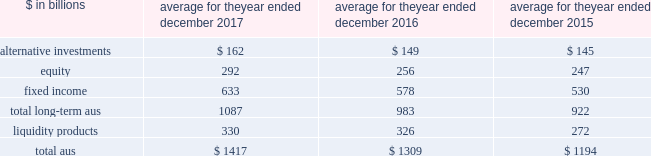The goldman sachs group , inc .
And subsidiaries management 2019s discussion and analysis the table below presents our average monthly assets under supervision by asset class .
Average for the year ended december $ in billions 2017 2016 2015 .
Operating environment .
During 2017 , investment management operated in an environment characterized by generally higher asset prices , resulting in appreciation in both equity and fixed income assets .
In addition , our long- term assets under supervision increased from net inflows primarily in fixed income and alternative investment assets .
These increases were partially offset by net outflows in liquidity products .
As a result , the mix of average assets under supervision during 2017 shifted slightly from liquidity products to long-term assets under supervision as compared to the mix at the end of 2016 .
In the future , if asset prices decline , or investors favor assets that typically generate lower fees or investors withdraw their assets , net revenues in investment management would likely be negatively impacted .
Following a challenging first quarter of 2016 , market conditions improved during the remainder of 2016 with higher asset prices resulting in full year appreciation in both equity and fixed income assets .
Also , our assets under supervision increased during 2016 from net inflows , primarily in fixed income assets , and liquidity products .
The mix of our average assets under supervision shifted slightly compared with 2015 from long-term assets under supervision to liquidity products .
Management fees were impacted by many factors , including inflows to advisory services and outflows from actively-managed mutual funds .
2017 versus 2016 .
Net revenues in investment management were $ 6.22 billion for 2017 , 7% ( 7 % ) higher than 2016 , due to higher management and other fees , reflecting higher average assets under supervision , and higher transaction revenues .
During the year , total assets under supervision increased $ 115 billion to $ 1.49 trillion .
Long- term assets under supervision increased $ 128 billion , including net market appreciation of $ 86 billion , primarily in equity and fixed income assets , and net inflows of $ 42 billion ( which includes $ 20 billion of inflows in connection with the verus acquisition and $ 5 billion of equity asset outflows in connection with the australian divestiture ) , primarily in fixed income and alternative investment assets .
Liquidity products decreased $ 13 billion ( which includes $ 3 billion of inflows in connection with the verus acquisition ) .
Operating expenses were $ 4.80 billion for 2017 , 3% ( 3 % ) higher than 2016 , primarily due to increased compensation and benefits expenses , reflecting higher net revenues .
Pre-tax earnings were $ 1.42 billion in 2017 , 25% ( 25 % ) higher than 2016 versus 2015 .
Net revenues in investment management were $ 5.79 billion for 2016 , 7% ( 7 % ) lower than 2015 .
This decrease primarily reflected significantly lower incentive fees compared with a strong 2015 .
In addition , management and other fees were slightly lower , reflecting shifts in the mix of client assets and strategies , partially offset by the impact of higher average assets under supervision .
During 2016 , total assets under supervision increased $ 127 billion to $ 1.38 trillion .
Long-term assets under supervision increased $ 75 billion , including net inflows of $ 42 billion , primarily in fixed income assets , and net market appreciation of $ 33 billion , primarily in equity and fixed income assets .
In addition , liquidity products increased $ 52 billion .
Operating expenses were $ 4.65 billion for 2016 , 4% ( 4 % ) lower than 2015 , due to decreased compensation and benefits expenses , reflecting lower net revenues .
Pre-tax earnings were $ 1.13 billion in 2016 , 17% ( 17 % ) lower than 2015 .
Geographic data see note 25 to the consolidated financial statements for a summary of our total net revenues , pre-tax earnings and net earnings by geographic region .
Goldman sachs 2017 form 10-k 63 .
In billions for 2017 , 2016 , and 2015 , what was the average in alternative investments? 
Computations: table_average(alternative investments, none)
Answer: 152.0. 